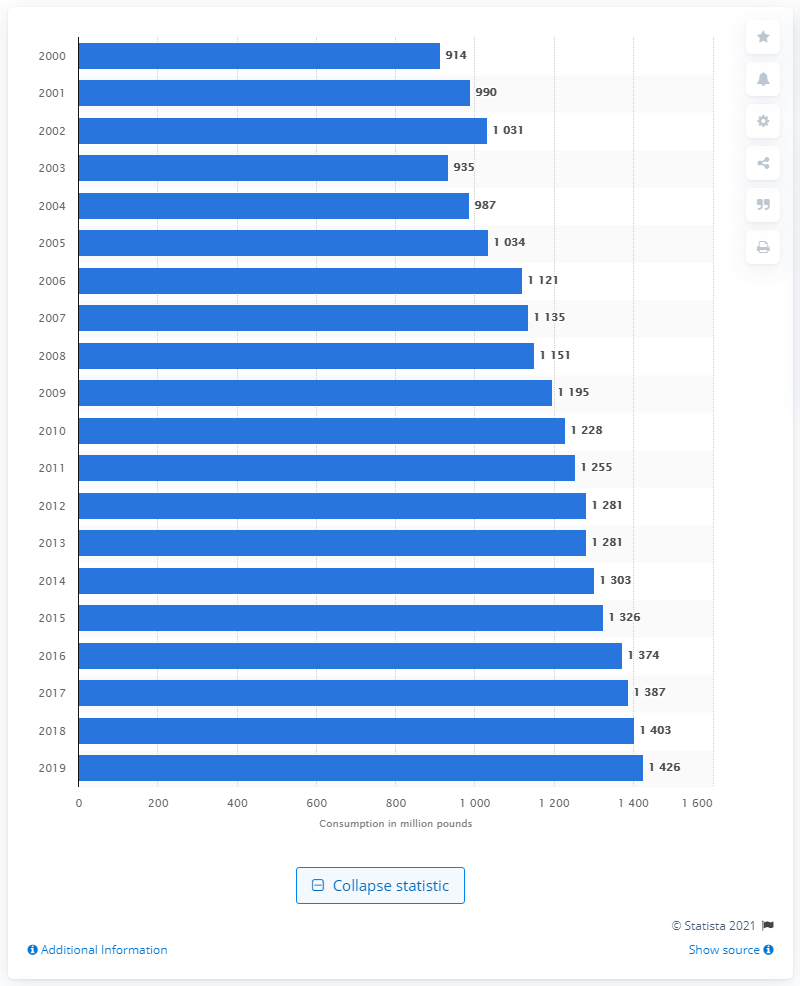Mention a couple of crucial points in this snapshot. In the United States, an estimated 138,700 metric tons of sour cream was consumed in 2018. 